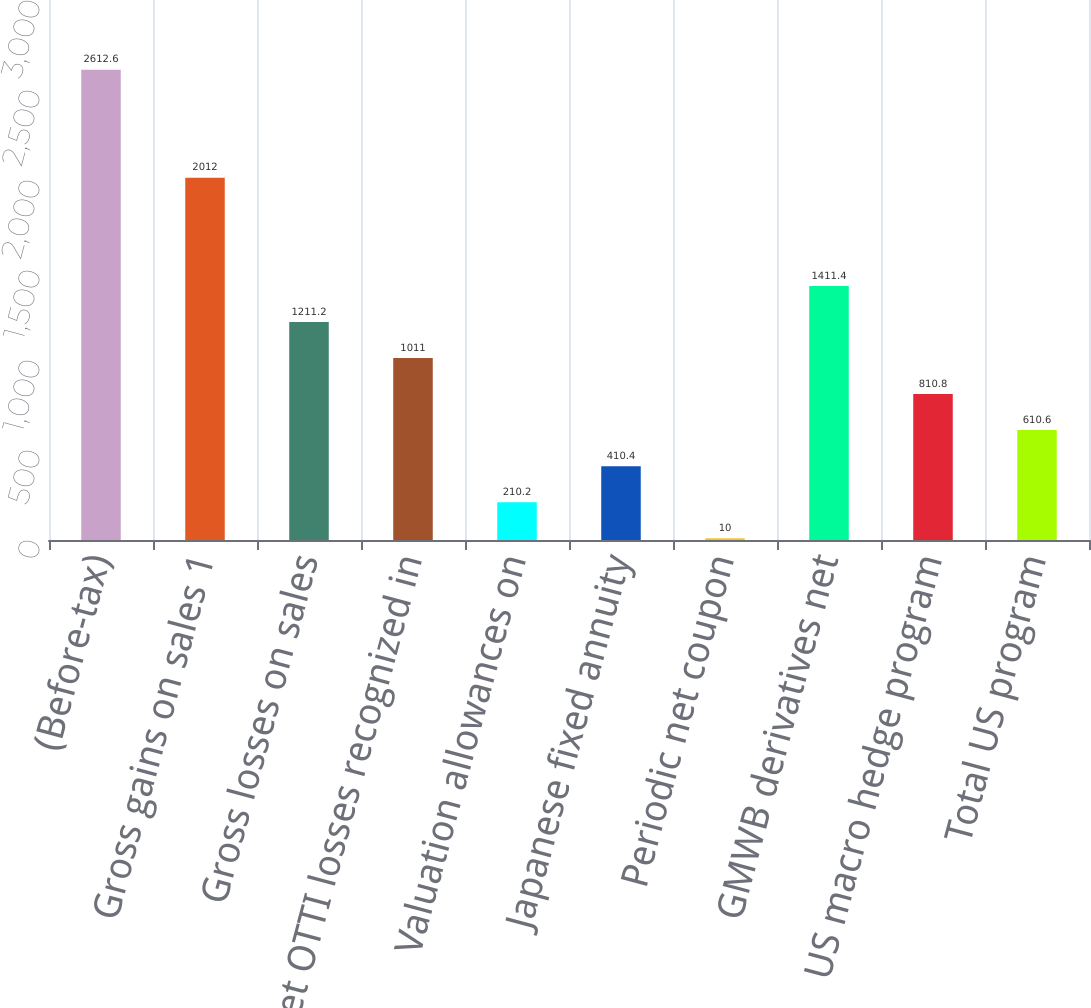Convert chart. <chart><loc_0><loc_0><loc_500><loc_500><bar_chart><fcel>(Before-tax)<fcel>Gross gains on sales 1<fcel>Gross losses on sales<fcel>Net OTTI losses recognized in<fcel>Valuation allowances on<fcel>Japanese fixed annuity<fcel>Periodic net coupon<fcel>GMWB derivatives net<fcel>US macro hedge program<fcel>Total US program<nl><fcel>2612.6<fcel>2012<fcel>1211.2<fcel>1011<fcel>210.2<fcel>410.4<fcel>10<fcel>1411.4<fcel>810.8<fcel>610.6<nl></chart> 